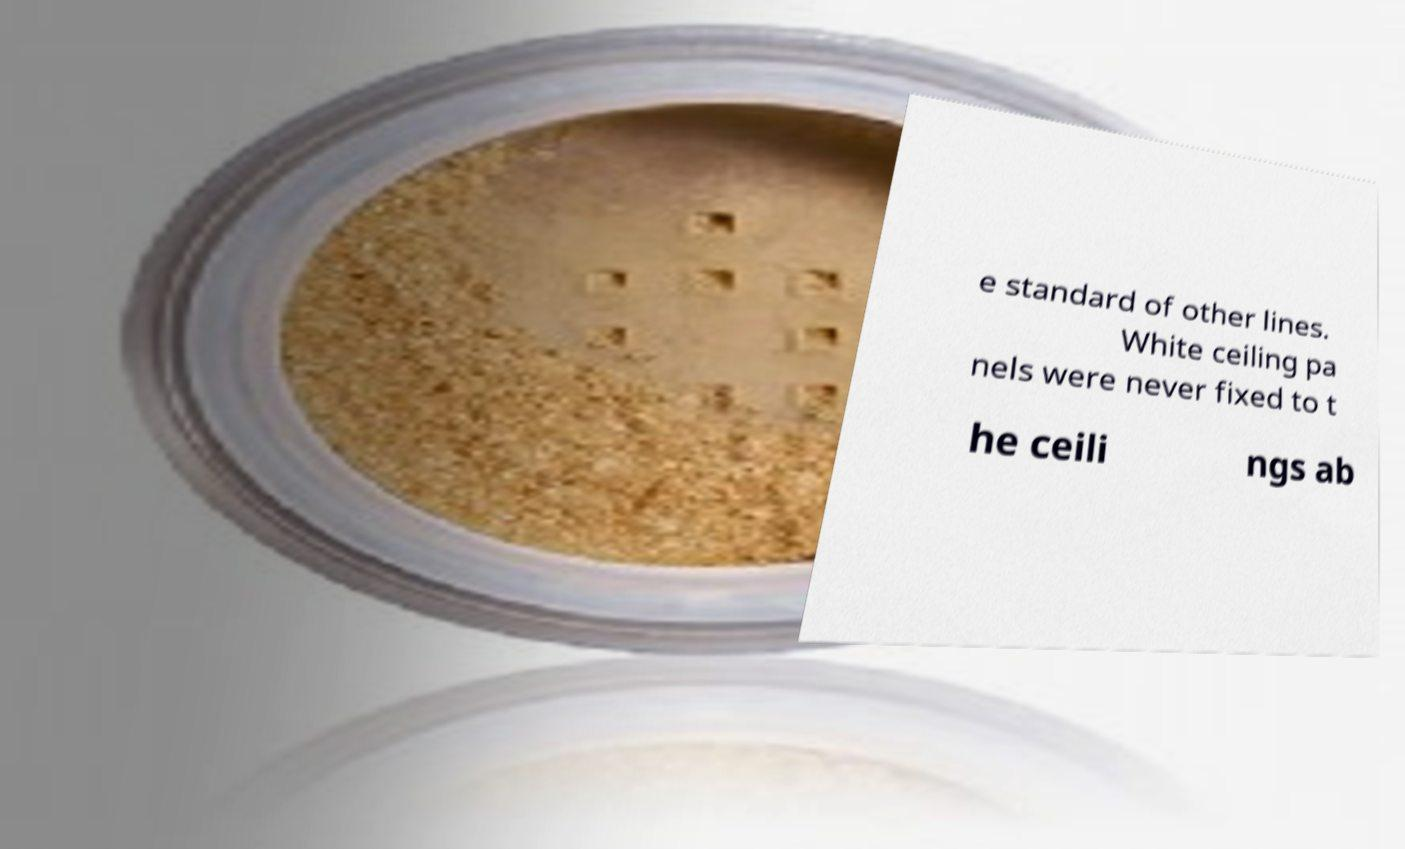For documentation purposes, I need the text within this image transcribed. Could you provide that? e standard of other lines. White ceiling pa nels were never fixed to t he ceili ngs ab 